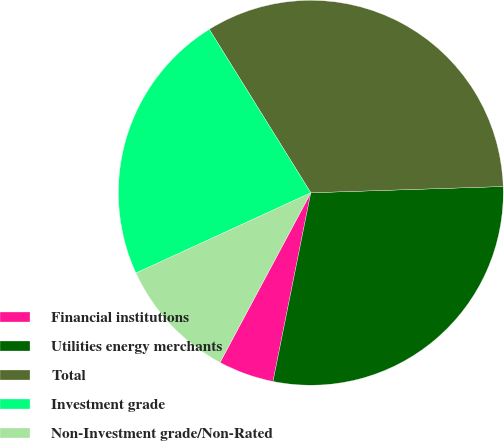Convert chart to OTSL. <chart><loc_0><loc_0><loc_500><loc_500><pie_chart><fcel>Financial institutions<fcel>Utilities energy merchants<fcel>Total<fcel>Investment grade<fcel>Non-Investment grade/Non-Rated<nl><fcel>4.67%<fcel>28.67%<fcel>33.33%<fcel>23.0%<fcel>10.33%<nl></chart> 